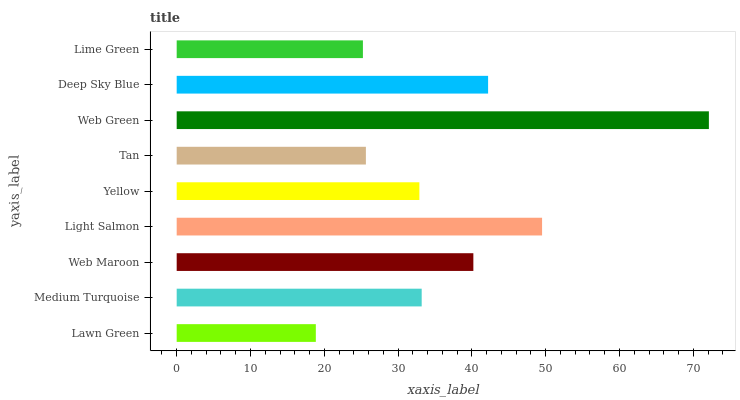Is Lawn Green the minimum?
Answer yes or no. Yes. Is Web Green the maximum?
Answer yes or no. Yes. Is Medium Turquoise the minimum?
Answer yes or no. No. Is Medium Turquoise the maximum?
Answer yes or no. No. Is Medium Turquoise greater than Lawn Green?
Answer yes or no. Yes. Is Lawn Green less than Medium Turquoise?
Answer yes or no. Yes. Is Lawn Green greater than Medium Turquoise?
Answer yes or no. No. Is Medium Turquoise less than Lawn Green?
Answer yes or no. No. Is Medium Turquoise the high median?
Answer yes or no. Yes. Is Medium Turquoise the low median?
Answer yes or no. Yes. Is Deep Sky Blue the high median?
Answer yes or no. No. Is Lawn Green the low median?
Answer yes or no. No. 